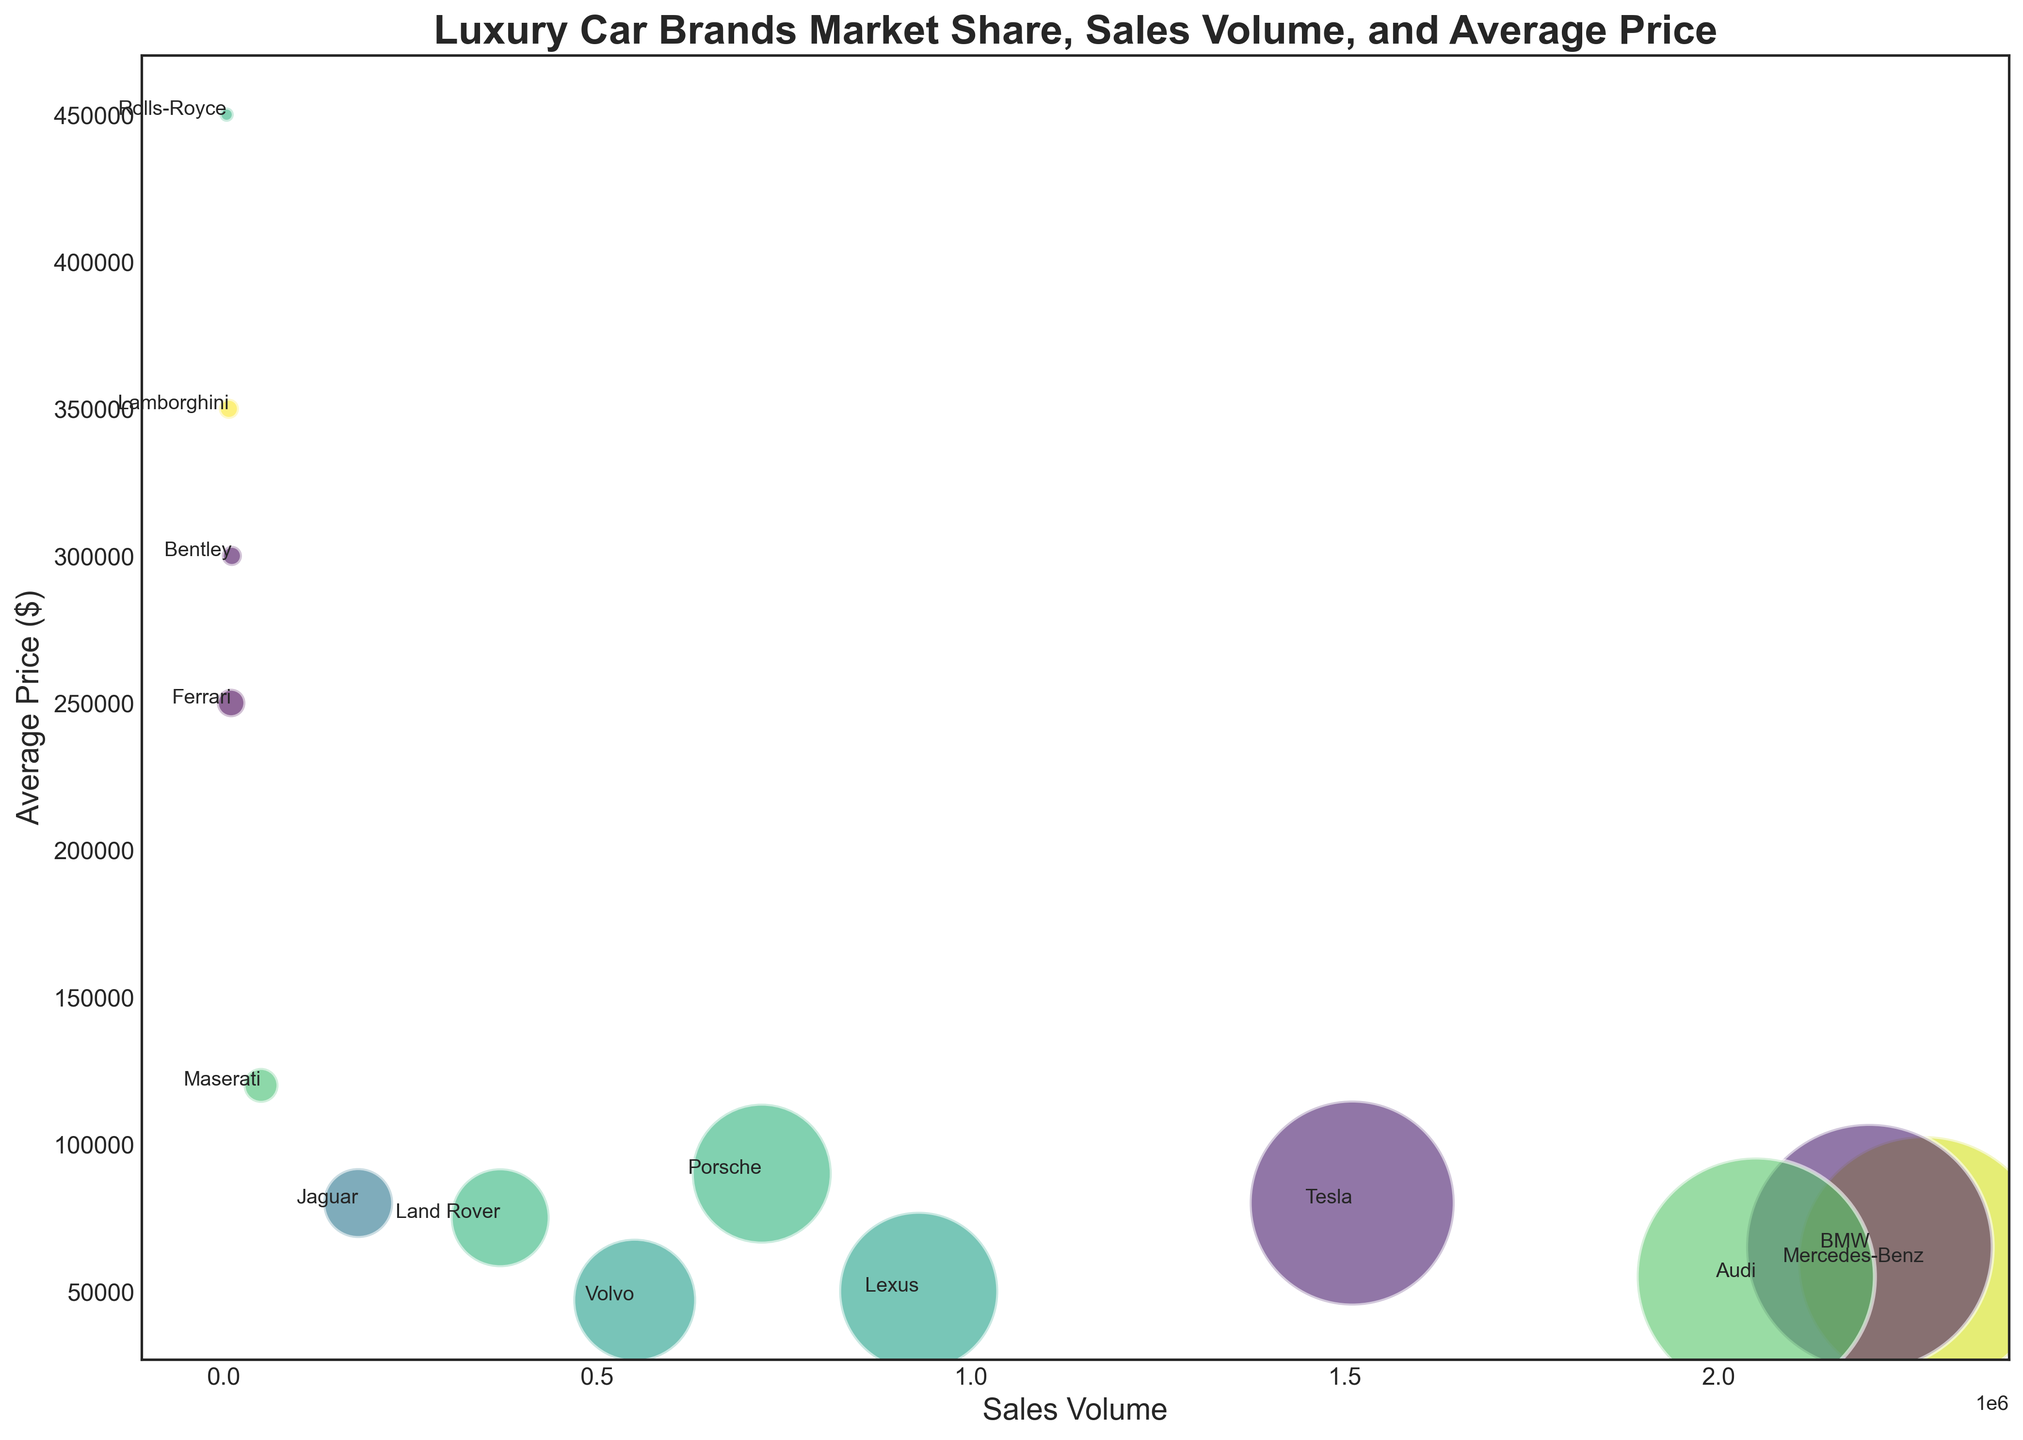Which brand has the highest market share? By looking at the figure, identify the largest bubble, as market share is represented by bubble size. The bubble for Mercedes-Benz is the largest.
Answer: Mercedes-Benz Which brand is the most expensive on average? Look at the y-axis to find the highest point. The highest point corresponds to Rolls-Royce with an average price of $450,000.
Answer: Rolls-Royce Which brand has a higher sales volume, Tesla or Audi? Find the bubble labeled Tesla and the bubble labeled Audi on the x-axis. Compare their positions; Tesla's bubble is further right.
Answer: Tesla What's the combined market share of Bentley and Lamborghini? Locate both Bentley and Lamborghini bubbles. Bentley has a market share of 0.1%, and Lamborghini also has 0.1%. Add them together: 0.1% + 0.1% = 0.2%.
Answer: 0.2% What is the average price difference between BMW and Jaguar? Locate the bubbles for BMW and Jaguar on the y-axis. BMW's average price is $65,000, and Jaguar's is $80,000. Subtract the lower value from the higher: $80,000 - $65,000 = $15,000.
Answer: $15,000 Which brand has a higher average price, Land Rover or Lexus? Find the bubbles labeled Land Rover and Lexus on the y-axis. Land Rover is at $75,000, and Lexus is at $50,000. Land Rover is higher.
Answer: Land Rover What is the combined sales volume of all brands with an average price above $100,000? Identify the brands with average prices above $100,000: Maserati (50,000), Ferrari (10,000), Lamborghini (7,000), Rolls-Royce (4,000), and Bentley (11,000). Add their sales volumes: 50,000 + 10,000 + 7,000 + 4,000 + 11,000 = 82,000.
Answer: 82,000 Which brand has a lower average price, Porsche or Volvo? Locate the bubbles labeled Porsche and Volvo on the y-axis. Porsche is at $90,000, and Volvo is at $47,000, so Volvo has a lower average price.
Answer: Volvo What is the total market share of brands with an average price below $50,000? Identify brands with average prices below $50,000: Volvo (3.7%) and Lexus (6.2%). Add their market shares: 3.7% + 6.2% = 9.9%.
Answer: 9.9% Which brand, among Tesla and Maserati, has a larger market share? Compare the size of the bubbles for Tesla and Maserati. Tesla has a market share of 10.3%, while Maserati has 0.3%. Tesla's bubble is larger.
Answer: Tesla 